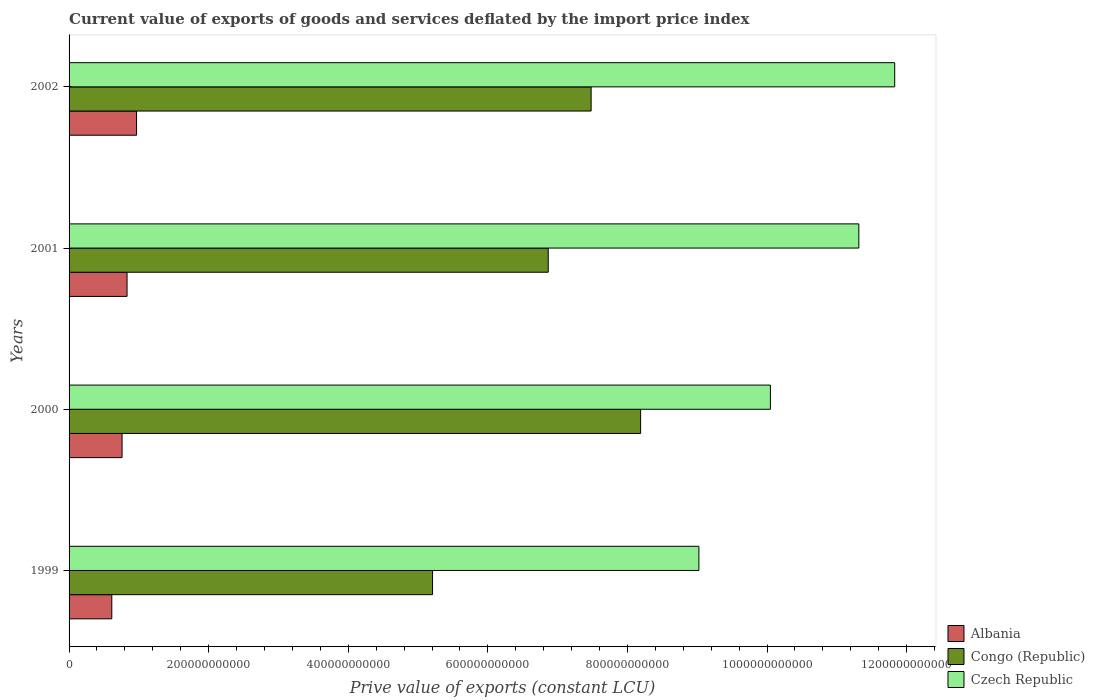Are the number of bars on each tick of the Y-axis equal?
Keep it short and to the point. Yes. How many bars are there on the 4th tick from the top?
Make the answer very short. 3. What is the label of the 3rd group of bars from the top?
Keep it short and to the point. 2000. In how many cases, is the number of bars for a given year not equal to the number of legend labels?
Make the answer very short. 0. What is the prive value of exports in Congo (Republic) in 2000?
Your response must be concise. 8.19e+11. Across all years, what is the maximum prive value of exports in Czech Republic?
Provide a short and direct response. 1.18e+12. Across all years, what is the minimum prive value of exports in Albania?
Offer a terse response. 6.12e+1. In which year was the prive value of exports in Albania minimum?
Your response must be concise. 1999. What is the total prive value of exports in Albania in the graph?
Your response must be concise. 3.17e+11. What is the difference between the prive value of exports in Czech Republic in 1999 and that in 2000?
Offer a terse response. -1.02e+11. What is the difference between the prive value of exports in Czech Republic in 2000 and the prive value of exports in Congo (Republic) in 2001?
Give a very brief answer. 3.18e+11. What is the average prive value of exports in Czech Republic per year?
Offer a very short reply. 1.06e+12. In the year 2000, what is the difference between the prive value of exports in Congo (Republic) and prive value of exports in Albania?
Keep it short and to the point. 7.43e+11. What is the ratio of the prive value of exports in Congo (Republic) in 2000 to that in 2001?
Your response must be concise. 1.19. Is the prive value of exports in Congo (Republic) in 1999 less than that in 2002?
Keep it short and to the point. Yes. What is the difference between the highest and the second highest prive value of exports in Albania?
Provide a succinct answer. 1.36e+1. What is the difference between the highest and the lowest prive value of exports in Czech Republic?
Offer a very short reply. 2.81e+11. What does the 1st bar from the top in 1999 represents?
Your answer should be compact. Czech Republic. What does the 1st bar from the bottom in 2001 represents?
Provide a succinct answer. Albania. Are all the bars in the graph horizontal?
Provide a succinct answer. Yes. How many years are there in the graph?
Keep it short and to the point. 4. What is the difference between two consecutive major ticks on the X-axis?
Make the answer very short. 2.00e+11. Does the graph contain grids?
Give a very brief answer. No. Where does the legend appear in the graph?
Give a very brief answer. Bottom right. How are the legend labels stacked?
Your answer should be very brief. Vertical. What is the title of the graph?
Your response must be concise. Current value of exports of goods and services deflated by the import price index. What is the label or title of the X-axis?
Provide a succinct answer. Prive value of exports (constant LCU). What is the label or title of the Y-axis?
Keep it short and to the point. Years. What is the Prive value of exports (constant LCU) in Albania in 1999?
Give a very brief answer. 6.12e+1. What is the Prive value of exports (constant LCU) in Congo (Republic) in 1999?
Your answer should be compact. 5.21e+11. What is the Prive value of exports (constant LCU) of Czech Republic in 1999?
Your answer should be very brief. 9.02e+11. What is the Prive value of exports (constant LCU) of Albania in 2000?
Your answer should be very brief. 7.59e+1. What is the Prive value of exports (constant LCU) of Congo (Republic) in 2000?
Provide a short and direct response. 8.19e+11. What is the Prive value of exports (constant LCU) in Czech Republic in 2000?
Keep it short and to the point. 1.00e+12. What is the Prive value of exports (constant LCU) of Albania in 2001?
Provide a succinct answer. 8.31e+1. What is the Prive value of exports (constant LCU) of Congo (Republic) in 2001?
Ensure brevity in your answer.  6.87e+11. What is the Prive value of exports (constant LCU) in Czech Republic in 2001?
Provide a short and direct response. 1.13e+12. What is the Prive value of exports (constant LCU) in Albania in 2002?
Your answer should be very brief. 9.67e+1. What is the Prive value of exports (constant LCU) of Congo (Republic) in 2002?
Your answer should be compact. 7.48e+11. What is the Prive value of exports (constant LCU) of Czech Republic in 2002?
Offer a very short reply. 1.18e+12. Across all years, what is the maximum Prive value of exports (constant LCU) in Albania?
Your answer should be compact. 9.67e+1. Across all years, what is the maximum Prive value of exports (constant LCU) of Congo (Republic)?
Provide a short and direct response. 8.19e+11. Across all years, what is the maximum Prive value of exports (constant LCU) of Czech Republic?
Provide a succinct answer. 1.18e+12. Across all years, what is the minimum Prive value of exports (constant LCU) in Albania?
Make the answer very short. 6.12e+1. Across all years, what is the minimum Prive value of exports (constant LCU) of Congo (Republic)?
Make the answer very short. 5.21e+11. Across all years, what is the minimum Prive value of exports (constant LCU) of Czech Republic?
Provide a short and direct response. 9.02e+11. What is the total Prive value of exports (constant LCU) in Albania in the graph?
Offer a terse response. 3.17e+11. What is the total Prive value of exports (constant LCU) of Congo (Republic) in the graph?
Your answer should be compact. 2.77e+12. What is the total Prive value of exports (constant LCU) of Czech Republic in the graph?
Offer a very short reply. 4.22e+12. What is the difference between the Prive value of exports (constant LCU) in Albania in 1999 and that in 2000?
Give a very brief answer. -1.47e+1. What is the difference between the Prive value of exports (constant LCU) of Congo (Republic) in 1999 and that in 2000?
Your answer should be compact. -2.98e+11. What is the difference between the Prive value of exports (constant LCU) in Czech Republic in 1999 and that in 2000?
Make the answer very short. -1.02e+11. What is the difference between the Prive value of exports (constant LCU) in Albania in 1999 and that in 2001?
Provide a succinct answer. -2.19e+1. What is the difference between the Prive value of exports (constant LCU) in Congo (Republic) in 1999 and that in 2001?
Give a very brief answer. -1.66e+11. What is the difference between the Prive value of exports (constant LCU) in Czech Republic in 1999 and that in 2001?
Ensure brevity in your answer.  -2.29e+11. What is the difference between the Prive value of exports (constant LCU) of Albania in 1999 and that in 2002?
Provide a short and direct response. -3.55e+1. What is the difference between the Prive value of exports (constant LCU) of Congo (Republic) in 1999 and that in 2002?
Make the answer very short. -2.27e+11. What is the difference between the Prive value of exports (constant LCU) in Czech Republic in 1999 and that in 2002?
Offer a very short reply. -2.81e+11. What is the difference between the Prive value of exports (constant LCU) in Albania in 2000 and that in 2001?
Your answer should be compact. -7.15e+09. What is the difference between the Prive value of exports (constant LCU) of Congo (Republic) in 2000 and that in 2001?
Keep it short and to the point. 1.32e+11. What is the difference between the Prive value of exports (constant LCU) of Czech Republic in 2000 and that in 2001?
Keep it short and to the point. -1.27e+11. What is the difference between the Prive value of exports (constant LCU) in Albania in 2000 and that in 2002?
Provide a succinct answer. -2.08e+1. What is the difference between the Prive value of exports (constant LCU) in Congo (Republic) in 2000 and that in 2002?
Your answer should be very brief. 7.09e+1. What is the difference between the Prive value of exports (constant LCU) of Czech Republic in 2000 and that in 2002?
Provide a short and direct response. -1.78e+11. What is the difference between the Prive value of exports (constant LCU) of Albania in 2001 and that in 2002?
Offer a very short reply. -1.36e+1. What is the difference between the Prive value of exports (constant LCU) of Congo (Republic) in 2001 and that in 2002?
Offer a terse response. -6.14e+1. What is the difference between the Prive value of exports (constant LCU) of Czech Republic in 2001 and that in 2002?
Keep it short and to the point. -5.14e+1. What is the difference between the Prive value of exports (constant LCU) of Albania in 1999 and the Prive value of exports (constant LCU) of Congo (Republic) in 2000?
Provide a succinct answer. -7.58e+11. What is the difference between the Prive value of exports (constant LCU) of Albania in 1999 and the Prive value of exports (constant LCU) of Czech Republic in 2000?
Provide a short and direct response. -9.44e+11. What is the difference between the Prive value of exports (constant LCU) in Congo (Republic) in 1999 and the Prive value of exports (constant LCU) in Czech Republic in 2000?
Offer a terse response. -4.84e+11. What is the difference between the Prive value of exports (constant LCU) in Albania in 1999 and the Prive value of exports (constant LCU) in Congo (Republic) in 2001?
Offer a very short reply. -6.25e+11. What is the difference between the Prive value of exports (constant LCU) of Albania in 1999 and the Prive value of exports (constant LCU) of Czech Republic in 2001?
Your answer should be compact. -1.07e+12. What is the difference between the Prive value of exports (constant LCU) of Congo (Republic) in 1999 and the Prive value of exports (constant LCU) of Czech Republic in 2001?
Your answer should be compact. -6.11e+11. What is the difference between the Prive value of exports (constant LCU) of Albania in 1999 and the Prive value of exports (constant LCU) of Congo (Republic) in 2002?
Offer a very short reply. -6.87e+11. What is the difference between the Prive value of exports (constant LCU) of Albania in 1999 and the Prive value of exports (constant LCU) of Czech Republic in 2002?
Your answer should be very brief. -1.12e+12. What is the difference between the Prive value of exports (constant LCU) of Congo (Republic) in 1999 and the Prive value of exports (constant LCU) of Czech Republic in 2002?
Give a very brief answer. -6.62e+11. What is the difference between the Prive value of exports (constant LCU) in Albania in 2000 and the Prive value of exports (constant LCU) in Congo (Republic) in 2001?
Provide a succinct answer. -6.11e+11. What is the difference between the Prive value of exports (constant LCU) in Albania in 2000 and the Prive value of exports (constant LCU) in Czech Republic in 2001?
Offer a very short reply. -1.06e+12. What is the difference between the Prive value of exports (constant LCU) of Congo (Republic) in 2000 and the Prive value of exports (constant LCU) of Czech Republic in 2001?
Ensure brevity in your answer.  -3.13e+11. What is the difference between the Prive value of exports (constant LCU) in Albania in 2000 and the Prive value of exports (constant LCU) in Congo (Republic) in 2002?
Offer a terse response. -6.72e+11. What is the difference between the Prive value of exports (constant LCU) of Albania in 2000 and the Prive value of exports (constant LCU) of Czech Republic in 2002?
Offer a terse response. -1.11e+12. What is the difference between the Prive value of exports (constant LCU) in Congo (Republic) in 2000 and the Prive value of exports (constant LCU) in Czech Republic in 2002?
Offer a very short reply. -3.64e+11. What is the difference between the Prive value of exports (constant LCU) of Albania in 2001 and the Prive value of exports (constant LCU) of Congo (Republic) in 2002?
Your response must be concise. -6.65e+11. What is the difference between the Prive value of exports (constant LCU) in Albania in 2001 and the Prive value of exports (constant LCU) in Czech Republic in 2002?
Offer a terse response. -1.10e+12. What is the difference between the Prive value of exports (constant LCU) in Congo (Republic) in 2001 and the Prive value of exports (constant LCU) in Czech Republic in 2002?
Offer a terse response. -4.96e+11. What is the average Prive value of exports (constant LCU) in Albania per year?
Keep it short and to the point. 7.92e+1. What is the average Prive value of exports (constant LCU) of Congo (Republic) per year?
Keep it short and to the point. 6.94e+11. What is the average Prive value of exports (constant LCU) in Czech Republic per year?
Provide a short and direct response. 1.06e+12. In the year 1999, what is the difference between the Prive value of exports (constant LCU) in Albania and Prive value of exports (constant LCU) in Congo (Republic)?
Offer a very short reply. -4.60e+11. In the year 1999, what is the difference between the Prive value of exports (constant LCU) of Albania and Prive value of exports (constant LCU) of Czech Republic?
Keep it short and to the point. -8.41e+11. In the year 1999, what is the difference between the Prive value of exports (constant LCU) of Congo (Republic) and Prive value of exports (constant LCU) of Czech Republic?
Provide a succinct answer. -3.82e+11. In the year 2000, what is the difference between the Prive value of exports (constant LCU) in Albania and Prive value of exports (constant LCU) in Congo (Republic)?
Keep it short and to the point. -7.43e+11. In the year 2000, what is the difference between the Prive value of exports (constant LCU) in Albania and Prive value of exports (constant LCU) in Czech Republic?
Your answer should be very brief. -9.29e+11. In the year 2000, what is the difference between the Prive value of exports (constant LCU) in Congo (Republic) and Prive value of exports (constant LCU) in Czech Republic?
Offer a very short reply. -1.86e+11. In the year 2001, what is the difference between the Prive value of exports (constant LCU) of Albania and Prive value of exports (constant LCU) of Congo (Republic)?
Provide a short and direct response. -6.03e+11. In the year 2001, what is the difference between the Prive value of exports (constant LCU) of Albania and Prive value of exports (constant LCU) of Czech Republic?
Make the answer very short. -1.05e+12. In the year 2001, what is the difference between the Prive value of exports (constant LCU) in Congo (Republic) and Prive value of exports (constant LCU) in Czech Republic?
Give a very brief answer. -4.45e+11. In the year 2002, what is the difference between the Prive value of exports (constant LCU) in Albania and Prive value of exports (constant LCU) in Congo (Republic)?
Ensure brevity in your answer.  -6.51e+11. In the year 2002, what is the difference between the Prive value of exports (constant LCU) of Albania and Prive value of exports (constant LCU) of Czech Republic?
Make the answer very short. -1.09e+12. In the year 2002, what is the difference between the Prive value of exports (constant LCU) in Congo (Republic) and Prive value of exports (constant LCU) in Czech Republic?
Your answer should be compact. -4.35e+11. What is the ratio of the Prive value of exports (constant LCU) in Albania in 1999 to that in 2000?
Offer a terse response. 0.81. What is the ratio of the Prive value of exports (constant LCU) of Congo (Republic) in 1999 to that in 2000?
Make the answer very short. 0.64. What is the ratio of the Prive value of exports (constant LCU) of Czech Republic in 1999 to that in 2000?
Your response must be concise. 0.9. What is the ratio of the Prive value of exports (constant LCU) of Albania in 1999 to that in 2001?
Give a very brief answer. 0.74. What is the ratio of the Prive value of exports (constant LCU) in Congo (Republic) in 1999 to that in 2001?
Offer a terse response. 0.76. What is the ratio of the Prive value of exports (constant LCU) in Czech Republic in 1999 to that in 2001?
Ensure brevity in your answer.  0.8. What is the ratio of the Prive value of exports (constant LCU) of Albania in 1999 to that in 2002?
Give a very brief answer. 0.63. What is the ratio of the Prive value of exports (constant LCU) of Congo (Republic) in 1999 to that in 2002?
Ensure brevity in your answer.  0.7. What is the ratio of the Prive value of exports (constant LCU) of Czech Republic in 1999 to that in 2002?
Your answer should be compact. 0.76. What is the ratio of the Prive value of exports (constant LCU) of Albania in 2000 to that in 2001?
Ensure brevity in your answer.  0.91. What is the ratio of the Prive value of exports (constant LCU) of Congo (Republic) in 2000 to that in 2001?
Give a very brief answer. 1.19. What is the ratio of the Prive value of exports (constant LCU) of Czech Republic in 2000 to that in 2001?
Provide a short and direct response. 0.89. What is the ratio of the Prive value of exports (constant LCU) in Albania in 2000 to that in 2002?
Keep it short and to the point. 0.79. What is the ratio of the Prive value of exports (constant LCU) of Congo (Republic) in 2000 to that in 2002?
Offer a very short reply. 1.09. What is the ratio of the Prive value of exports (constant LCU) in Czech Republic in 2000 to that in 2002?
Your answer should be compact. 0.85. What is the ratio of the Prive value of exports (constant LCU) in Albania in 2001 to that in 2002?
Your answer should be very brief. 0.86. What is the ratio of the Prive value of exports (constant LCU) of Congo (Republic) in 2001 to that in 2002?
Ensure brevity in your answer.  0.92. What is the ratio of the Prive value of exports (constant LCU) of Czech Republic in 2001 to that in 2002?
Give a very brief answer. 0.96. What is the difference between the highest and the second highest Prive value of exports (constant LCU) in Albania?
Your answer should be very brief. 1.36e+1. What is the difference between the highest and the second highest Prive value of exports (constant LCU) of Congo (Republic)?
Keep it short and to the point. 7.09e+1. What is the difference between the highest and the second highest Prive value of exports (constant LCU) of Czech Republic?
Ensure brevity in your answer.  5.14e+1. What is the difference between the highest and the lowest Prive value of exports (constant LCU) of Albania?
Your answer should be compact. 3.55e+1. What is the difference between the highest and the lowest Prive value of exports (constant LCU) in Congo (Republic)?
Offer a terse response. 2.98e+11. What is the difference between the highest and the lowest Prive value of exports (constant LCU) of Czech Republic?
Your answer should be compact. 2.81e+11. 